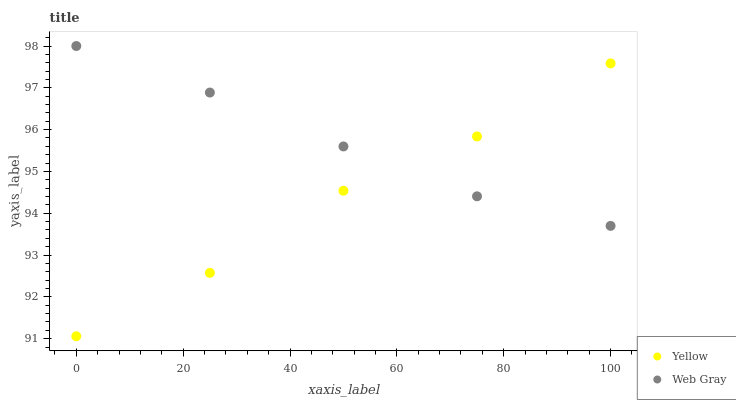Does Yellow have the minimum area under the curve?
Answer yes or no. Yes. Does Web Gray have the maximum area under the curve?
Answer yes or no. Yes. Does Yellow have the maximum area under the curve?
Answer yes or no. No. Is Web Gray the smoothest?
Answer yes or no. Yes. Is Yellow the roughest?
Answer yes or no. Yes. Is Yellow the smoothest?
Answer yes or no. No. Does Yellow have the lowest value?
Answer yes or no. Yes. Does Web Gray have the highest value?
Answer yes or no. Yes. Does Yellow have the highest value?
Answer yes or no. No. Does Yellow intersect Web Gray?
Answer yes or no. Yes. Is Yellow less than Web Gray?
Answer yes or no. No. Is Yellow greater than Web Gray?
Answer yes or no. No. 